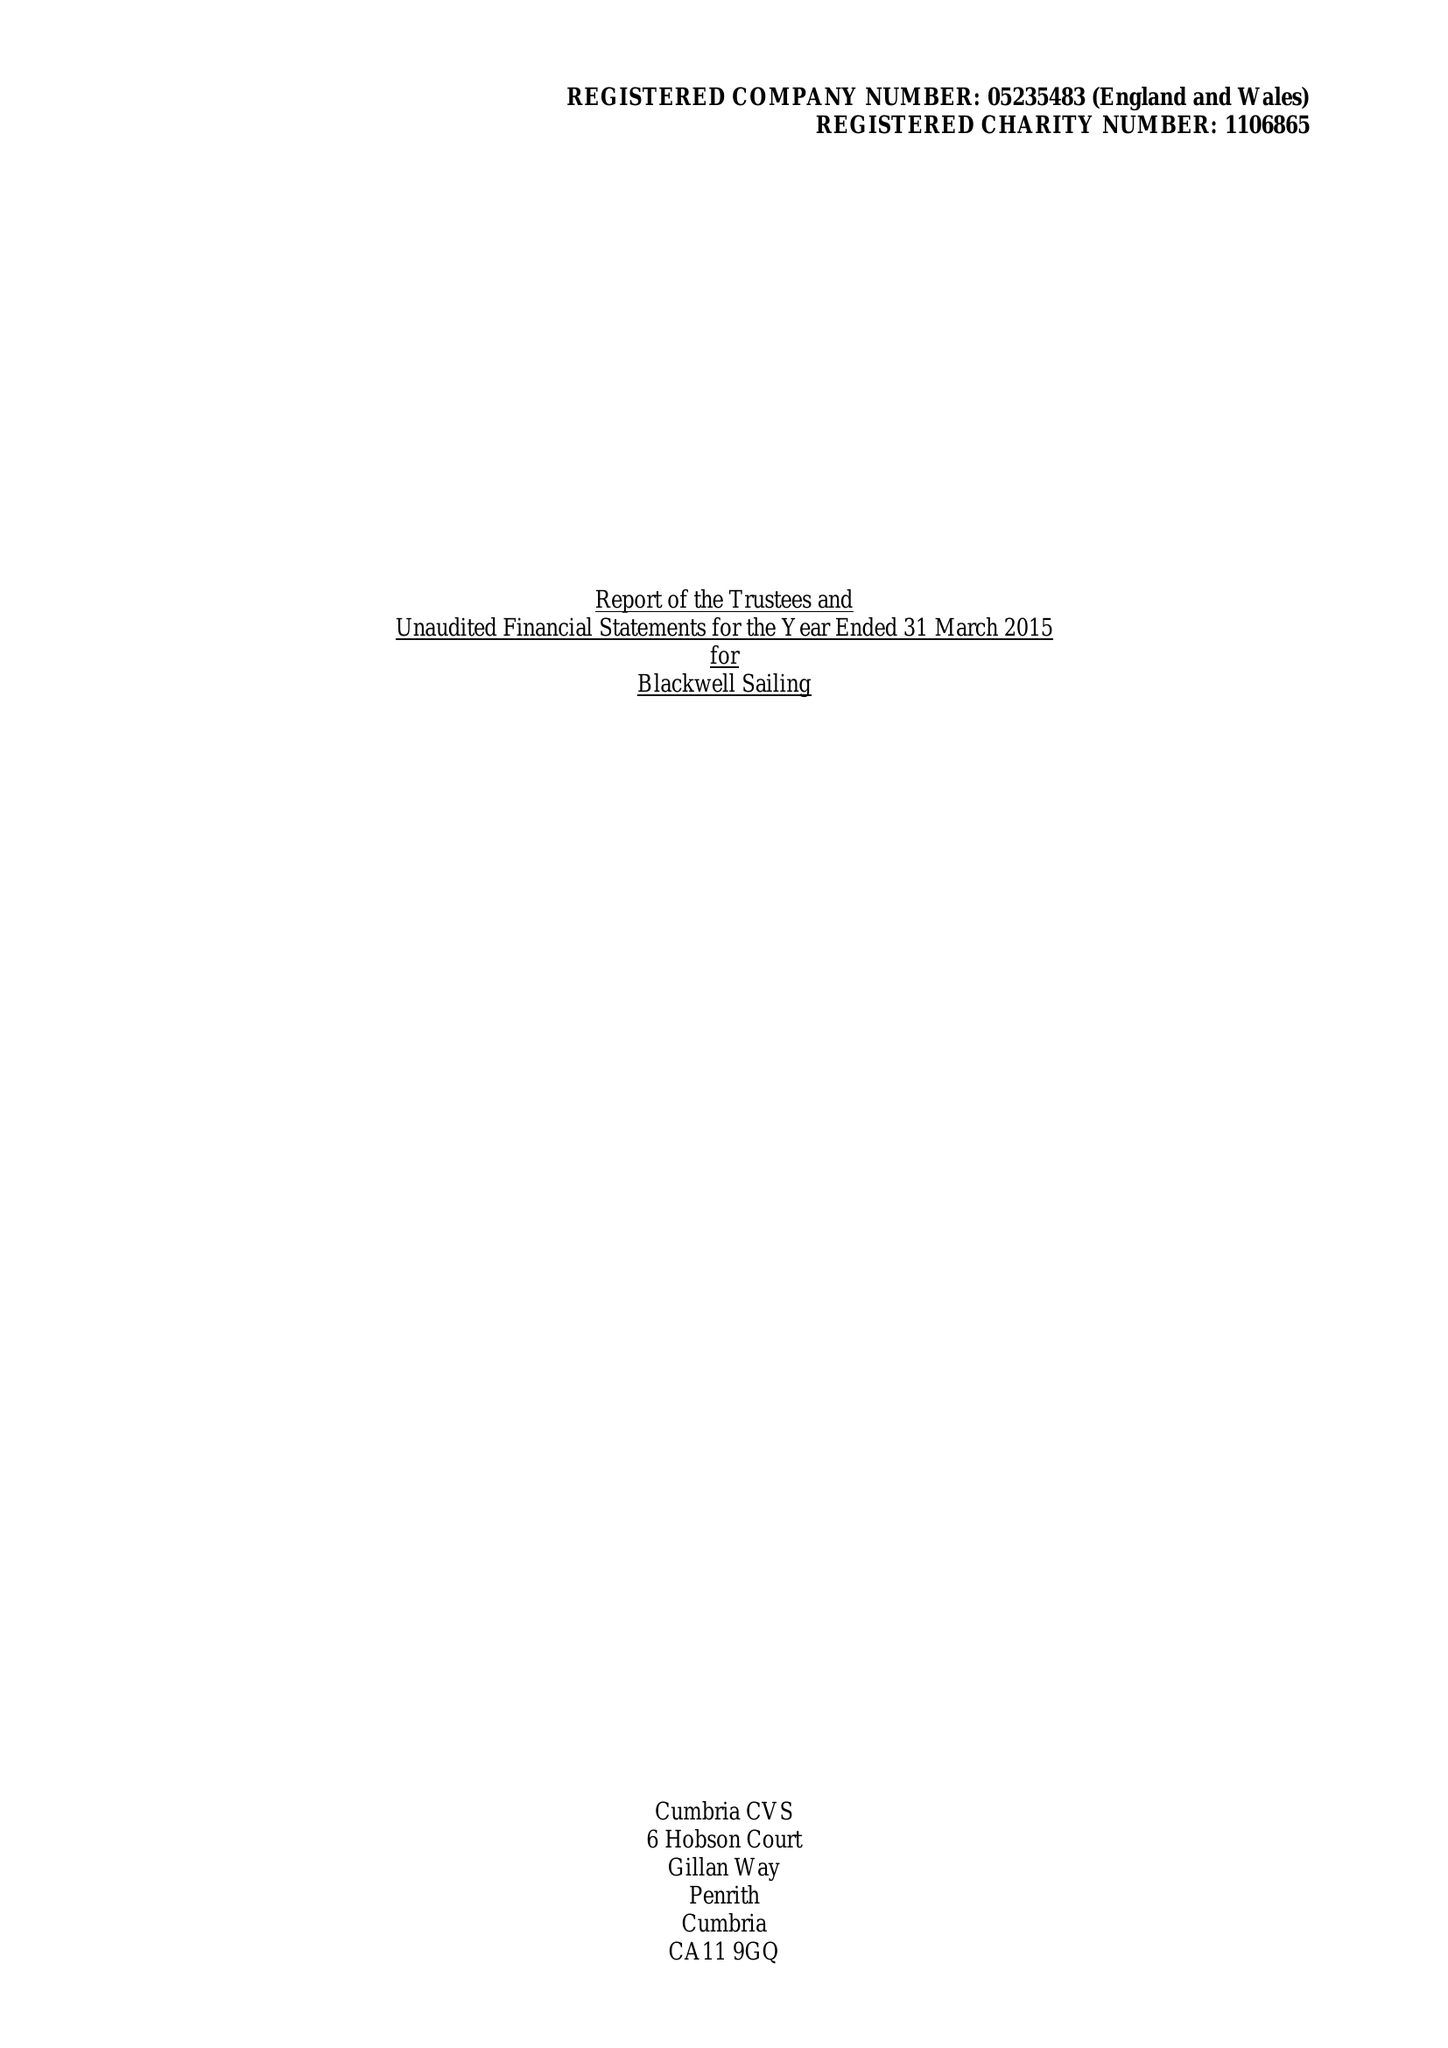What is the value for the report_date?
Answer the question using a single word or phrase. 2015-03-31 